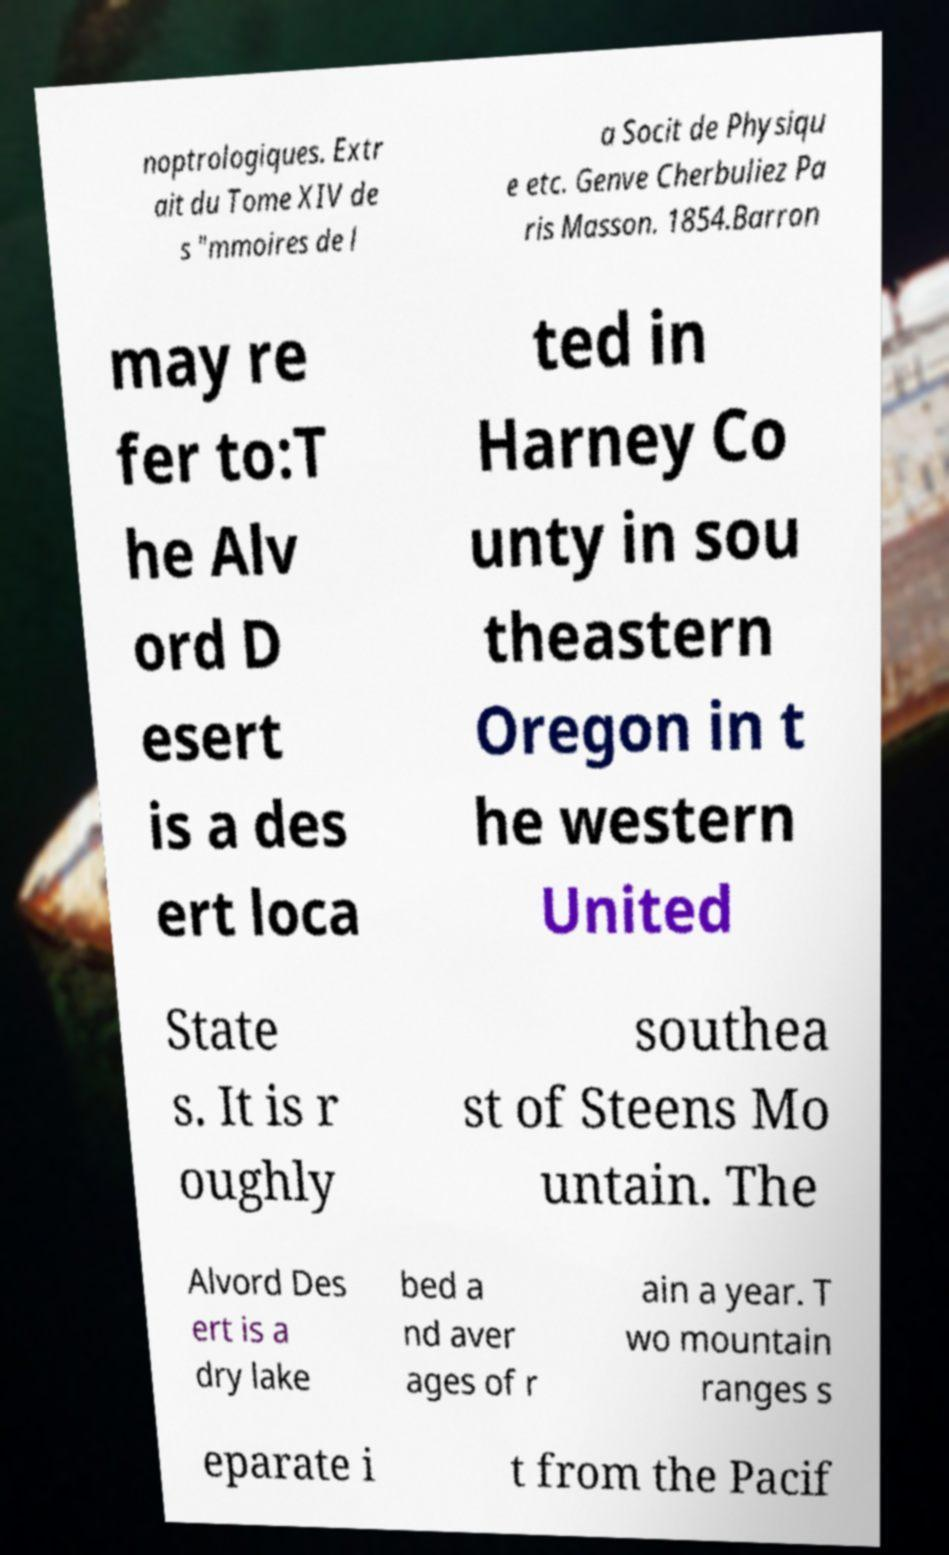Can you read and provide the text displayed in the image?This photo seems to have some interesting text. Can you extract and type it out for me? noptrologiques. Extr ait du Tome XIV de s "mmoires de l a Socit de Physiqu e etc. Genve Cherbuliez Pa ris Masson. 1854.Barron may re fer to:T he Alv ord D esert is a des ert loca ted in Harney Co unty in sou theastern Oregon in t he western United State s. It is r oughly southea st of Steens Mo untain. The Alvord Des ert is a dry lake bed a nd aver ages of r ain a year. T wo mountain ranges s eparate i t from the Pacif 